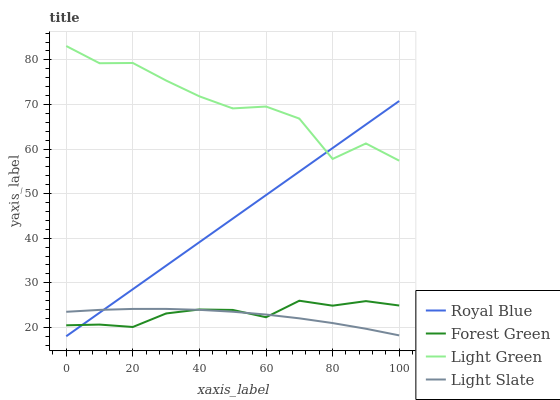Does Light Slate have the minimum area under the curve?
Answer yes or no. Yes. Does Light Green have the maximum area under the curve?
Answer yes or no. Yes. Does Royal Blue have the minimum area under the curve?
Answer yes or no. No. Does Royal Blue have the maximum area under the curve?
Answer yes or no. No. Is Royal Blue the smoothest?
Answer yes or no. Yes. Is Light Green the roughest?
Answer yes or no. Yes. Is Forest Green the smoothest?
Answer yes or no. No. Is Forest Green the roughest?
Answer yes or no. No. Does Royal Blue have the lowest value?
Answer yes or no. Yes. Does Forest Green have the lowest value?
Answer yes or no. No. Does Light Green have the highest value?
Answer yes or no. Yes. Does Royal Blue have the highest value?
Answer yes or no. No. Is Light Slate less than Light Green?
Answer yes or no. Yes. Is Light Green greater than Forest Green?
Answer yes or no. Yes. Does Light Slate intersect Forest Green?
Answer yes or no. Yes. Is Light Slate less than Forest Green?
Answer yes or no. No. Is Light Slate greater than Forest Green?
Answer yes or no. No. Does Light Slate intersect Light Green?
Answer yes or no. No. 